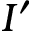Convert formula to latex. <formula><loc_0><loc_0><loc_500><loc_500>I ^ { \prime }</formula> 